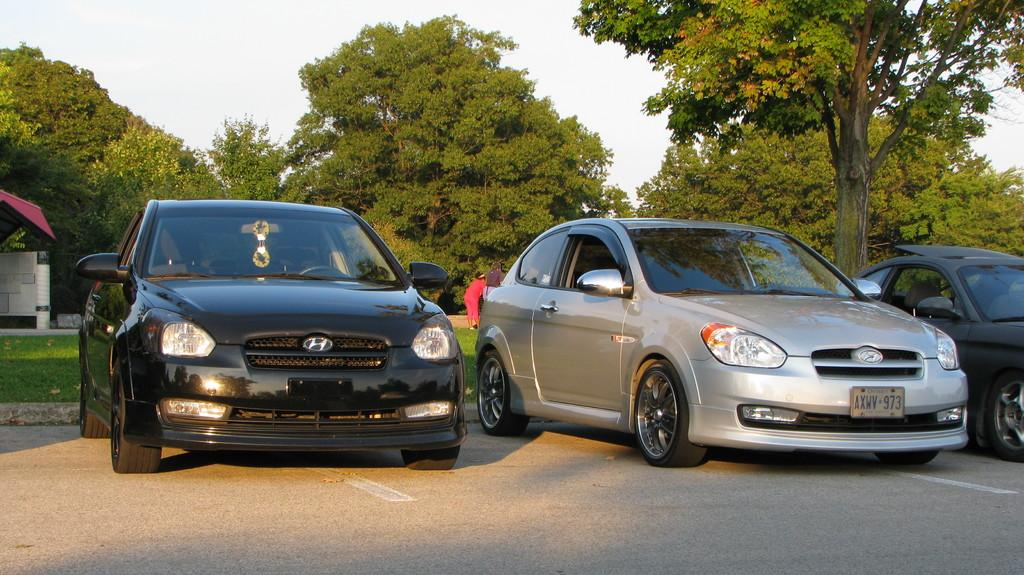What is happening on the road in the image? There are vehicles on the road in the image. Can you describe the background of the image? There is a person, trees, grass, and the sky visible in the background of the image. What else can be seen on the ground in the background of the image? There are other objects on the ground in the background of the image. How does the person in the background of the image experience loss? There is no indication in the image that the person is experiencing loss, as the image only shows vehicles on the road and the background elements. 